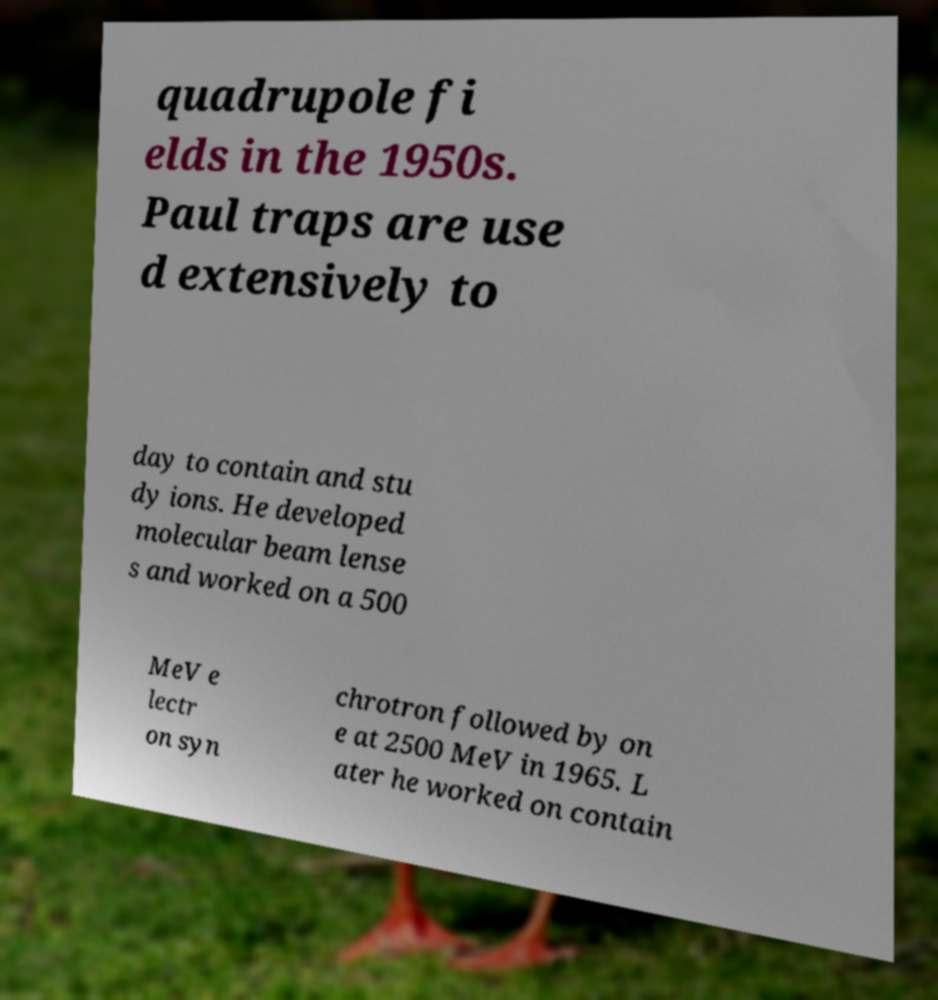For documentation purposes, I need the text within this image transcribed. Could you provide that? quadrupole fi elds in the 1950s. Paul traps are use d extensively to day to contain and stu dy ions. He developed molecular beam lense s and worked on a 500 MeV e lectr on syn chrotron followed by on e at 2500 MeV in 1965. L ater he worked on contain 